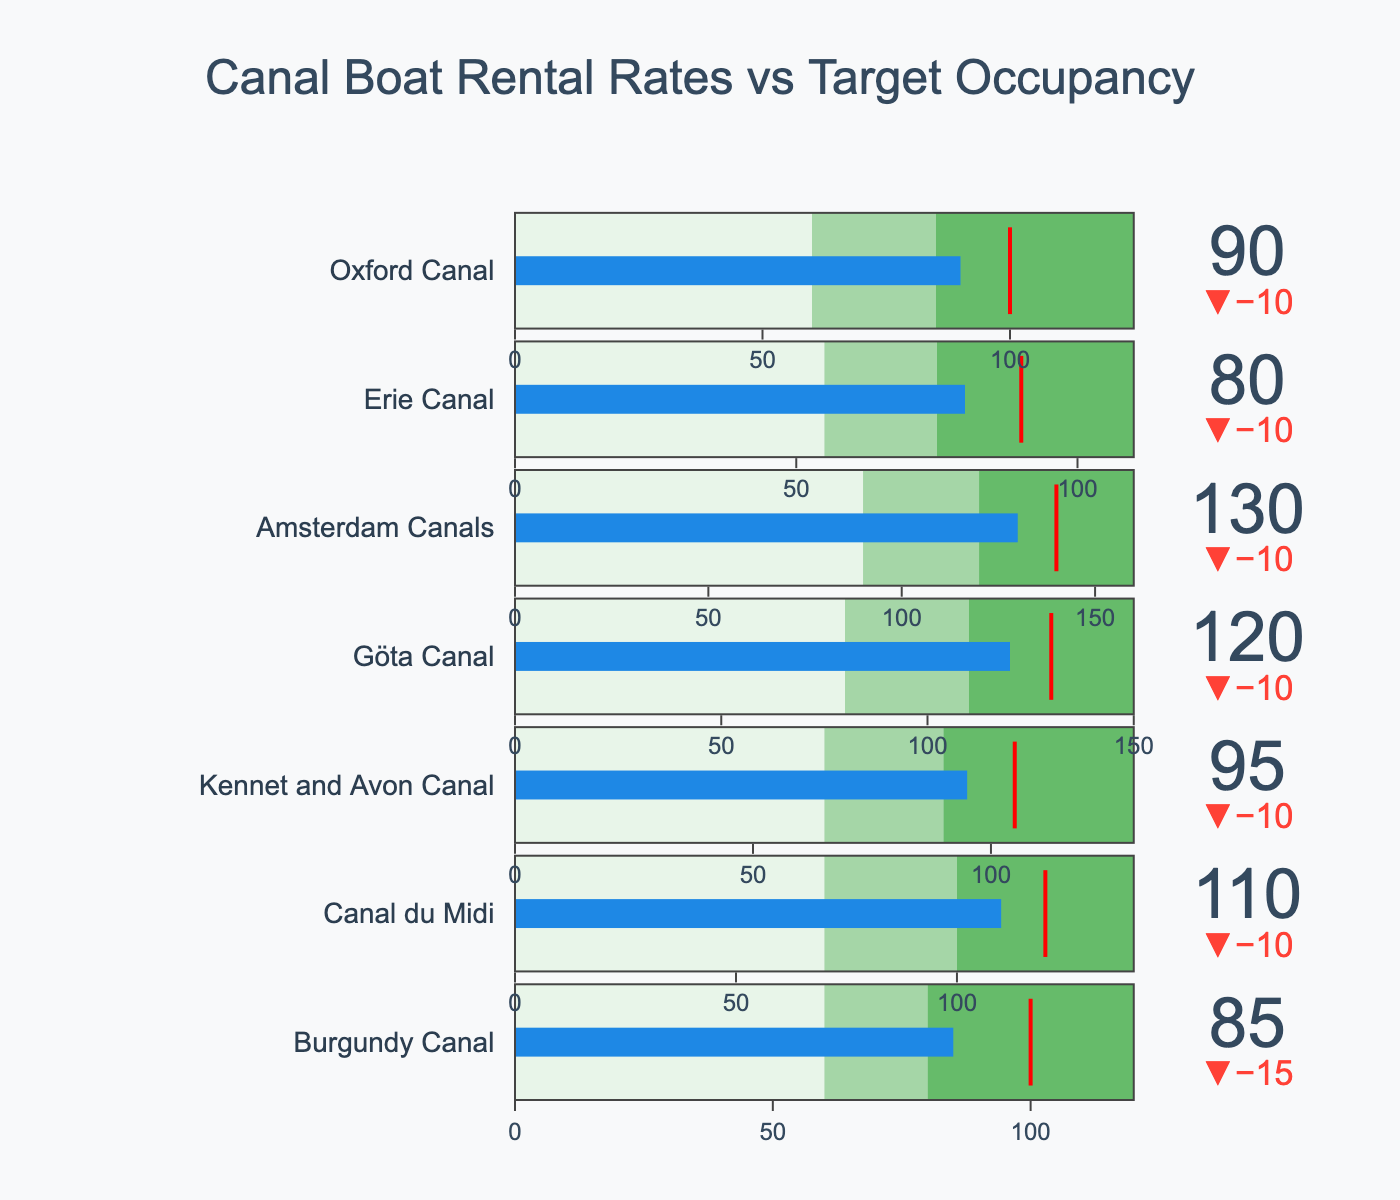What is the actual rental rate for the Amsterdam Canals? The figure shows the actual rental rates next to each canal name. For the Amsterdam Canals, the actual rental rate is shown as 130.
Answer: 130 Which canal has the highest target rental rate? The target rental rates are marked with a red line within each bullet gauge. By comparing the target rates across all canals, we see that the Amsterdam Canals have the highest target rental rate at 140.
Answer: Amsterdam Canals How many canals have an actual rental rate equal to or above 100? By inspecting each canal's actual rental rate, we find the following rates equal to or above 100: Canal du Midi (110), Kennet and Avon Canal (95, below 100), Göta Canal (120), Amsterdam Canals (130), and Oxford Canal (90, below 100). There are 3 canals that meet the criteria.
Answer: 3 Which canal has the smallest difference between actual and target rental rates? The differences can be calculated as follows: Burgundy Canal (100-85=15), Canal du Midi (120-110=10), Kennet and Avon Canal (105-95=10), Göta Canal (130-120=10), Amsterdam Canals (140-130=10), Erie Canal (90-80=10), Oxford Canal (100-90=10). The Canal du Midi, Kennet and Avon Canal, Göta Canal, Amsterdam Canals, Erie Canal, and Oxford Canal all share the smallest difference of 10.
Answer: Canal du Midi, Kennet and Avon Canal, Göta Canal, Amsterdam Canals, Erie Canal, Oxford Canal In the context of target rental rates, how many canals fall within the 'Medium' range for their actual rental rates? The segments in each bullet gauge denote 'Low', 'Medium', and 'High' ranges. Checking each canal, we have the following: Burgundy Canal (85, medium), Canal du Midi (110, medium), Kennet and Avon Canal (95, medium), Göta Canal (120, medium), Amsterdam Canals (130, medium), Erie Canal (80, medium), and Oxford Canal (90, medium). All canals fall within the 'Medium' range for their actual rental rates.
Answer: 7 Which canal exceeds its target rental rate the most? To determine which exceeds the most, compare the actual and target rates: Burgundy Canal (85, does not exceed), Canal du Midi (110, does not exceed), Kennet and Avon Canal (95, does not exceed), Göta Canal (120, does not exceed), Amsterdam Canals (130, does not exceed), Erie Canal (80, does not exceed), Oxford Canal (90, does not exceed). None of the canals exceed their target rental rates; all are below their targets.
Answer: None What is the range of the 'Low' rental rate for the Erie Canal? The 'Low' range is indicated in the bullet gauge from its starting point to the first color change. For the Erie Canal, the 'Low' range is from 0 to 55.
Answer: 0-55 